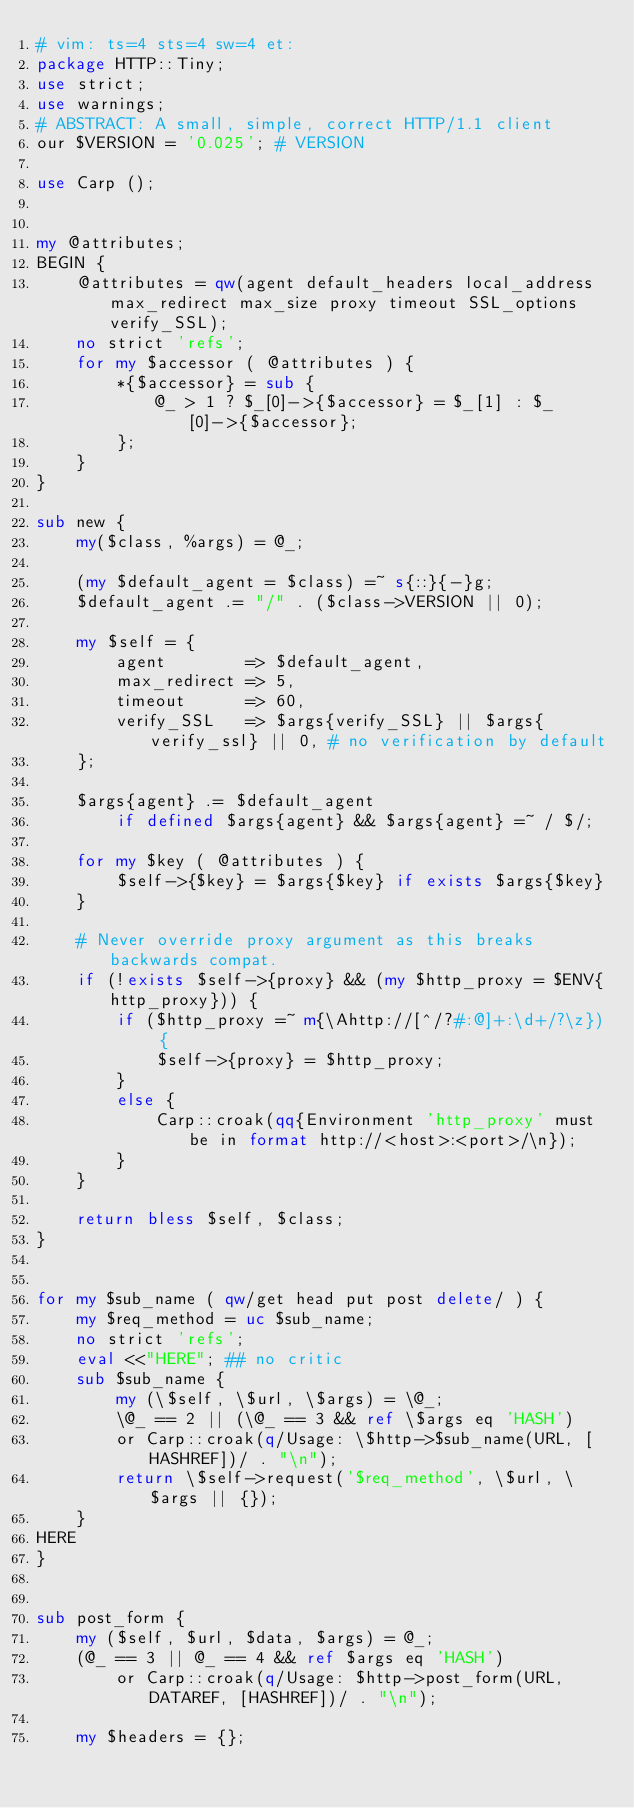Convert code to text. <code><loc_0><loc_0><loc_500><loc_500><_Perl_># vim: ts=4 sts=4 sw=4 et:
package HTTP::Tiny;
use strict;
use warnings;
# ABSTRACT: A small, simple, correct HTTP/1.1 client
our $VERSION = '0.025'; # VERSION

use Carp ();


my @attributes;
BEGIN {
    @attributes = qw(agent default_headers local_address max_redirect max_size proxy timeout SSL_options verify_SSL);
    no strict 'refs';
    for my $accessor ( @attributes ) {
        *{$accessor} = sub {
            @_ > 1 ? $_[0]->{$accessor} = $_[1] : $_[0]->{$accessor};
        };
    }
}

sub new {
    my($class, %args) = @_;

    (my $default_agent = $class) =~ s{::}{-}g;
    $default_agent .= "/" . ($class->VERSION || 0);

    my $self = {
        agent        => $default_agent,
        max_redirect => 5,
        timeout      => 60,
        verify_SSL   => $args{verify_SSL} || $args{verify_ssl} || 0, # no verification by default
    };

    $args{agent} .= $default_agent
        if defined $args{agent} && $args{agent} =~ / $/;

    for my $key ( @attributes ) {
        $self->{$key} = $args{$key} if exists $args{$key}
    }

    # Never override proxy argument as this breaks backwards compat.
    if (!exists $self->{proxy} && (my $http_proxy = $ENV{http_proxy})) {
        if ($http_proxy =~ m{\Ahttp://[^/?#:@]+:\d+/?\z}) {
            $self->{proxy} = $http_proxy;
        }
        else {
            Carp::croak(qq{Environment 'http_proxy' must be in format http://<host>:<port>/\n});
        }
    }

    return bless $self, $class;
}


for my $sub_name ( qw/get head put post delete/ ) {
    my $req_method = uc $sub_name;
    no strict 'refs';
    eval <<"HERE"; ## no critic
    sub $sub_name {
        my (\$self, \$url, \$args) = \@_;
        \@_ == 2 || (\@_ == 3 && ref \$args eq 'HASH')
        or Carp::croak(q/Usage: \$http->$sub_name(URL, [HASHREF])/ . "\n");
        return \$self->request('$req_method', \$url, \$args || {});
    }
HERE
}


sub post_form {
    my ($self, $url, $data, $args) = @_;
    (@_ == 3 || @_ == 4 && ref $args eq 'HASH')
        or Carp::croak(q/Usage: $http->post_form(URL, DATAREF, [HASHREF])/ . "\n");

    my $headers = {};</code> 